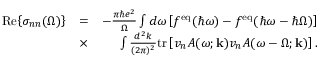<formula> <loc_0><loc_0><loc_500><loc_500>\begin{array} { r l r } { R e { \left \{ \sigma _ { n n } ( \Omega ) \right \} } } & { = } & { - \frac { \pi \hbar { e } ^ { 2 } } { \Omega } \int d \omega \left [ f ^ { e q } ( \hbar { \omega } ) - f ^ { e q } ( \hbar { \omega } - \hbar { \Omega } ) \right ] } \\ & { \times } & { \int \frac { d ^ { 2 } k } { ( 2 \pi ) ^ { 2 } } t r \left [ v _ { n } A ( \omega ; k ) v _ { n } A ( \omega - \Omega ; k ) \right ] . } \end{array}</formula> 